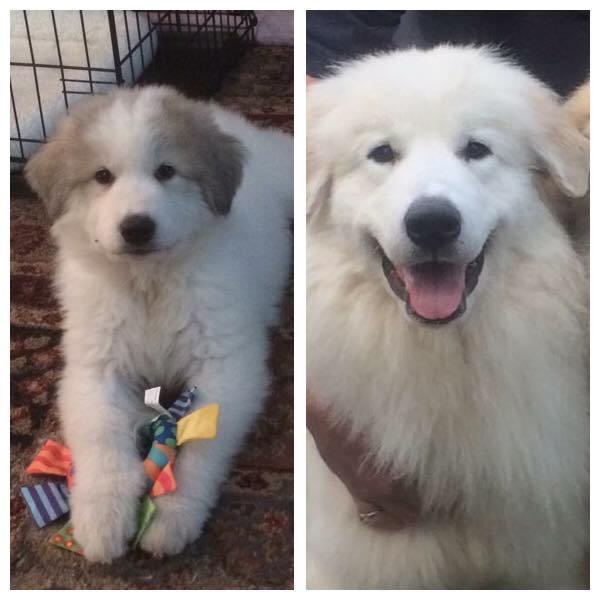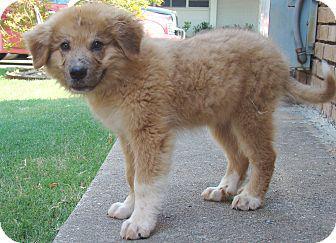The first image is the image on the left, the second image is the image on the right. Examine the images to the left and right. Is the description "Left image shows two dogs posed together outdoors." accurate? Answer yes or no. No. 